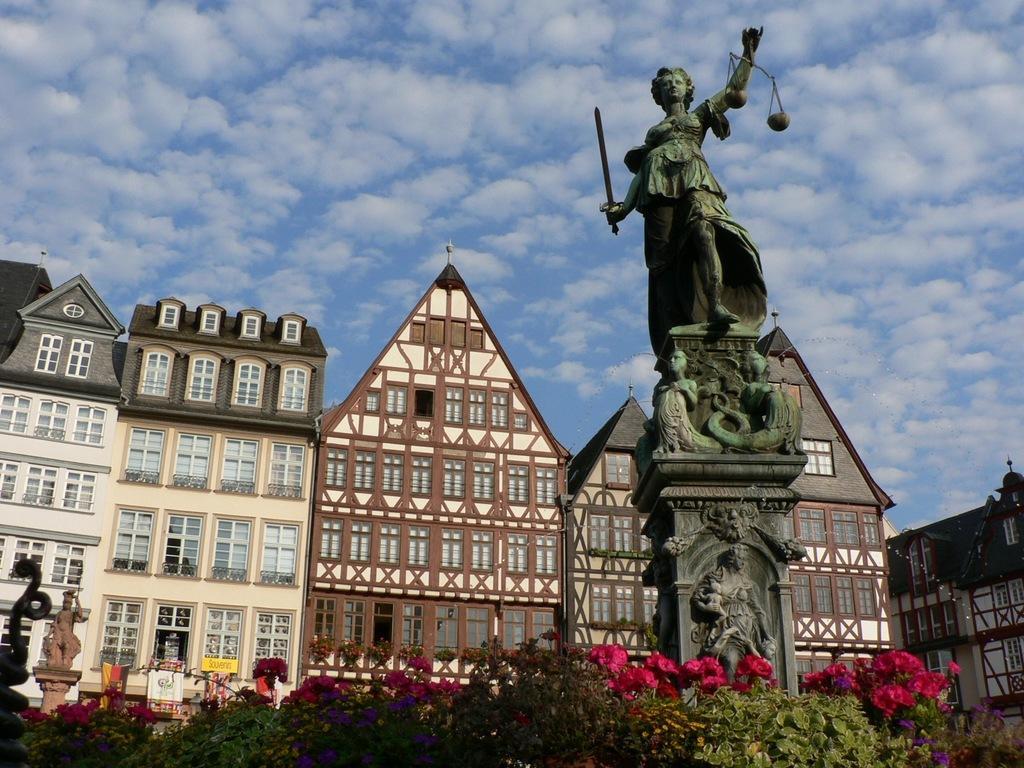Describe this image in one or two sentences. In this image, there are a few buildings. We can see some statues on pillars. We can also see some plants with flowers. We can see the sky with clouds. 